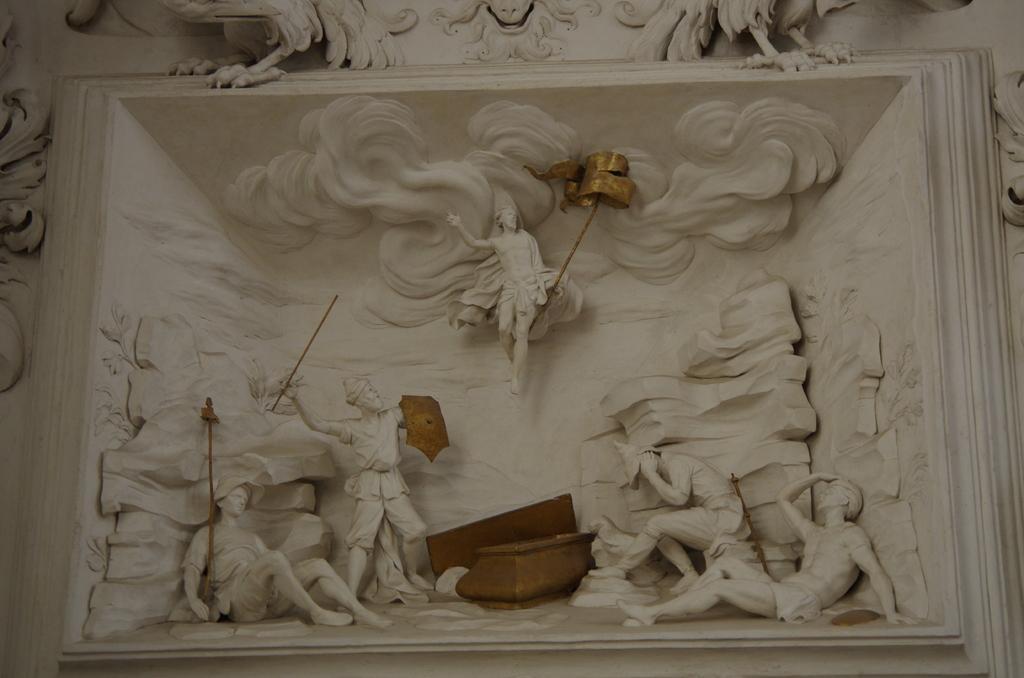Please provide a concise description of this image. This image looks like, it is handcrafted. There are some statues in the middle. 